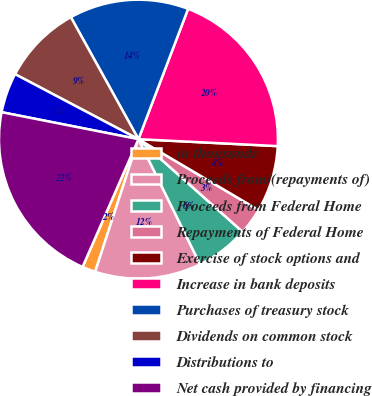Convert chart to OTSL. <chart><loc_0><loc_0><loc_500><loc_500><pie_chart><fcel>in thousands<fcel>Proceeds from/(repayments of)<fcel>Proceeds from Federal Home<fcel>Repayments of Federal Home<fcel>Exercise of stock options and<fcel>Increase in bank deposits<fcel>Purchases of treasury stock<fcel>Dividends on common stock<fcel>Distributions to<fcel>Net cash provided by financing<nl><fcel>1.54%<fcel>12.31%<fcel>6.15%<fcel>3.08%<fcel>7.69%<fcel>20.0%<fcel>13.85%<fcel>9.23%<fcel>4.62%<fcel>21.54%<nl></chart> 